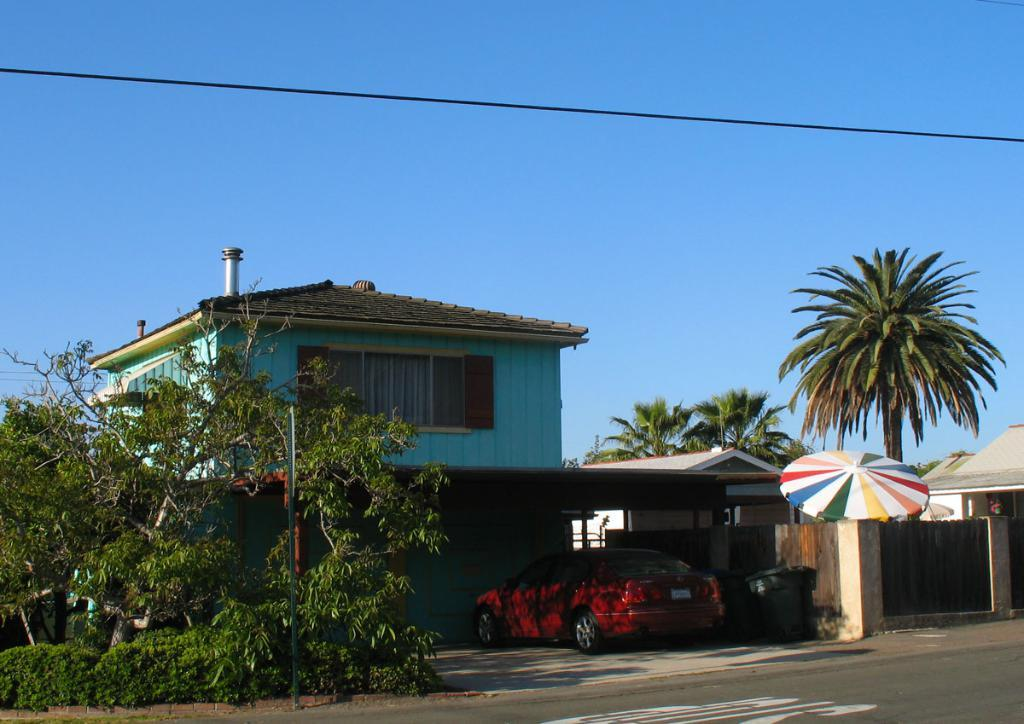What type of structures can be seen in the image? There are houses in the image. What architectural elements are present in the image? There are walls and a window visible in the image. What type of vegetation is present in the image? There are trees in the image. What other objects can be seen in the image? There is a pole, a vehicle, and an umbrella in the image. What is the ground surface like in the image? There is a road at the bottom of the image. What can be seen in the background of the image? The sky is visible in the background of the image. Are there any additional features in the image? There is a wire in the image. How many books are stacked on the pole in the image? There are no books present in the image, and the pole does not have any books stacked on it. Can you describe the kiss between the two trees in the image? There are no kisses or people depicted in the image, and the trees do not have any interaction with each other. 